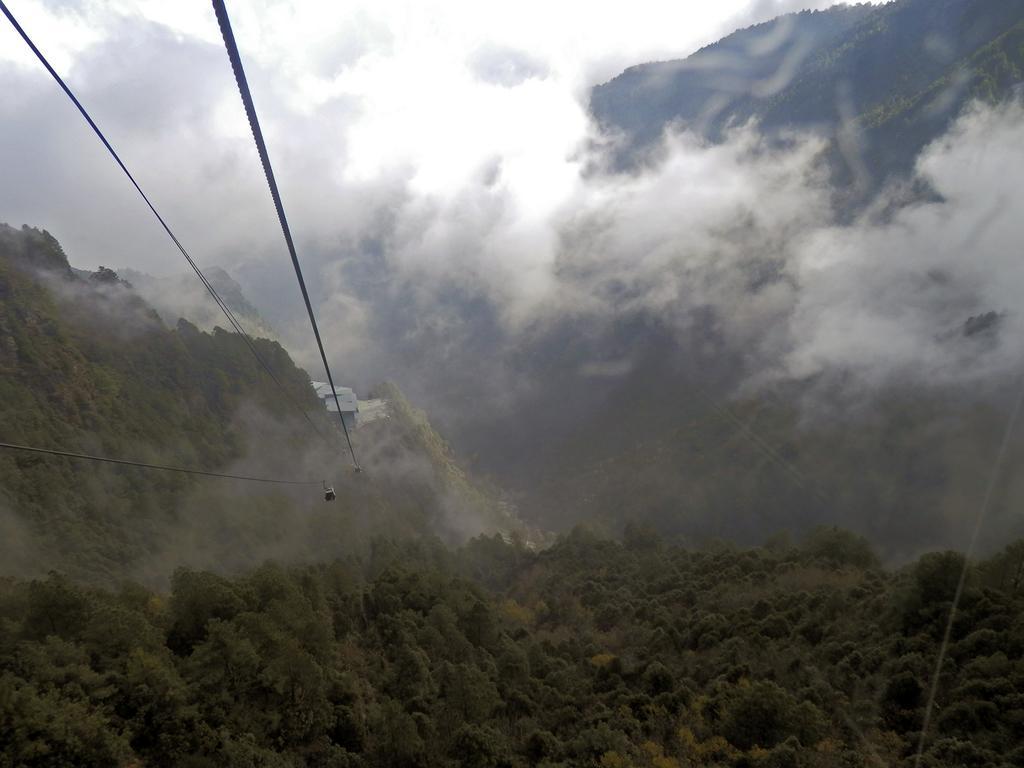How would you summarize this image in a sentence or two? This is a picture taken in a forest or in between the hills. In the foreground of the picture there are trees, cables, cable cars. In the center of the picture there are hills covered with trees and we can see houses, clouds moving. 